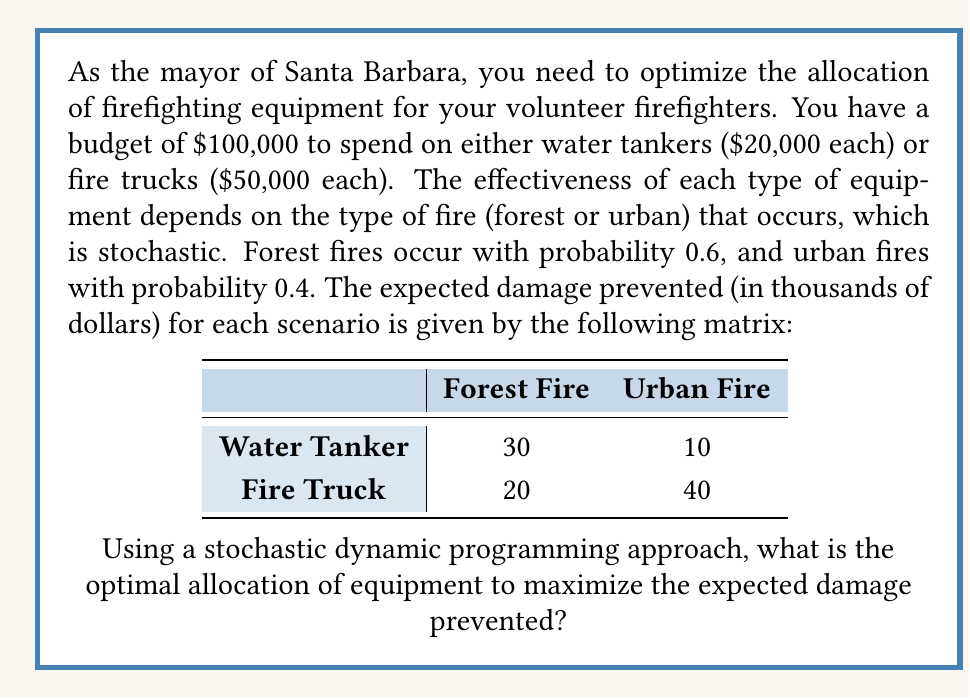Show me your answer to this math problem. Let's solve this problem using a stochastic dynamic programming approach:

1) First, let's define our state space. We can buy at most 5 water tankers or 2 fire trucks. Let $x$ be the number of water tankers and $y$ be the number of fire trucks.

2) Our constraint is:
   $20000x + 50000y \leq 100000$

3) The expected damage prevented for a given allocation $(x,y)$ is:
   $E[D(x,y)] = 0.6(30x + 20y) + 0.4(10x + 40y)$

4) Simplifying:
   $E[D(x,y)] = 22x + 28y$

5) Our objective is to maximize $E[D(x,y)]$ subject to the budget constraint.

6) We can solve this using the following recursive equation:
   $V(b) = \max\{22x + 28y + V(b - 20000x - 50000y)\}$
   where $b$ is the remaining budget, and $V(b)$ is the maximum expected damage prevention with budget $b$.

7) Starting from $b = 100000$, we have the following options:
   - Buy a water tanker: $V(100000) = 22 + V(80000)$
   - Buy a fire truck: $V(100000) = 28 + V(50000)$

8) Continuing this process, we find:
   $V(80000) = 22 + V(60000)$
   $V(60000) = 22 + V(40000)$
   $V(50000) = 22 + V(30000)$
   $V(40000) = 22 + V(20000)$
   $V(30000) = 22 + V(10000)$
   $V(20000) = 22 + V(0)$
   $V(10000) = 0$ (can't afford any more equipment)
   $V(0) = 0$

9) Working backwards:
   $V(20000) = 22$
   $V(30000) = 22$
   $V(40000) = 44$
   $V(50000) = 50$
   $V(60000) = 66$
   $V(80000) = 88$
   $V(100000) = 110$

10) The optimal path is to buy 5 water tankers, resulting in a maximum expected damage prevention of $110,000.
Answer: 5 water tankers 